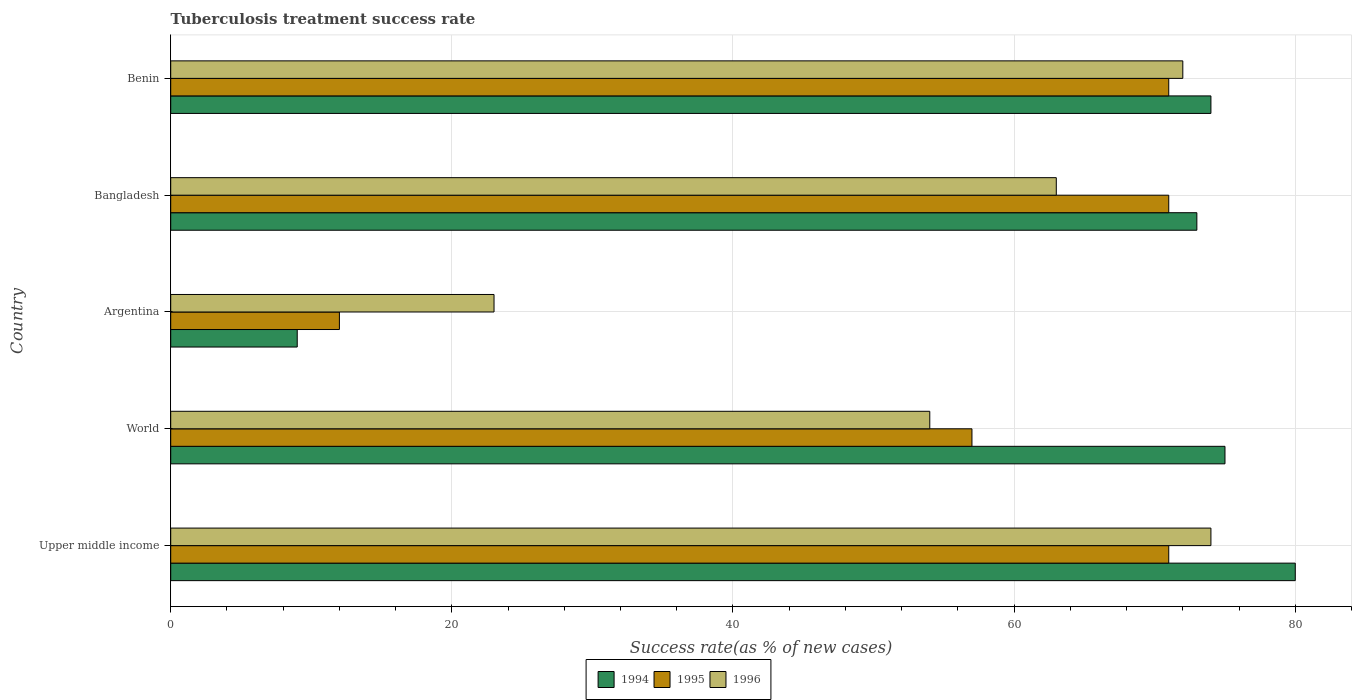How many different coloured bars are there?
Offer a terse response. 3. How many groups of bars are there?
Your answer should be compact. 5. How many bars are there on the 4th tick from the top?
Keep it short and to the point. 3. How many bars are there on the 1st tick from the bottom?
Keep it short and to the point. 3. In how many cases, is the number of bars for a given country not equal to the number of legend labels?
Ensure brevity in your answer.  0. In which country was the tuberculosis treatment success rate in 1995 maximum?
Offer a very short reply. Upper middle income. What is the total tuberculosis treatment success rate in 1994 in the graph?
Give a very brief answer. 311. What is the difference between the tuberculosis treatment success rate in 1995 in Argentina and the tuberculosis treatment success rate in 1996 in Benin?
Offer a terse response. -60. What is the average tuberculosis treatment success rate in 1996 per country?
Provide a succinct answer. 57.2. What is the difference between the tuberculosis treatment success rate in 1995 and tuberculosis treatment success rate in 1996 in Argentina?
Offer a terse response. -11. What is the ratio of the tuberculosis treatment success rate in 1994 in Benin to that in World?
Ensure brevity in your answer.  0.99. Is the difference between the tuberculosis treatment success rate in 1995 in Bangladesh and Benin greater than the difference between the tuberculosis treatment success rate in 1996 in Bangladesh and Benin?
Provide a short and direct response. Yes. What is the difference between the highest and the second highest tuberculosis treatment success rate in 1995?
Your answer should be compact. 0. What is the difference between the highest and the lowest tuberculosis treatment success rate in 1996?
Provide a succinct answer. 51. In how many countries, is the tuberculosis treatment success rate in 1996 greater than the average tuberculosis treatment success rate in 1996 taken over all countries?
Provide a short and direct response. 3. Is the sum of the tuberculosis treatment success rate in 1996 in Argentina and Upper middle income greater than the maximum tuberculosis treatment success rate in 1995 across all countries?
Offer a very short reply. Yes. What does the 2nd bar from the top in Benin represents?
Your answer should be very brief. 1995. What does the 2nd bar from the bottom in World represents?
Your answer should be very brief. 1995. Is it the case that in every country, the sum of the tuberculosis treatment success rate in 1994 and tuberculosis treatment success rate in 1995 is greater than the tuberculosis treatment success rate in 1996?
Ensure brevity in your answer.  No. Are all the bars in the graph horizontal?
Give a very brief answer. Yes. How many countries are there in the graph?
Provide a short and direct response. 5. What is the difference between two consecutive major ticks on the X-axis?
Keep it short and to the point. 20. Does the graph contain any zero values?
Your answer should be compact. No. What is the title of the graph?
Your answer should be very brief. Tuberculosis treatment success rate. What is the label or title of the X-axis?
Provide a succinct answer. Success rate(as % of new cases). What is the Success rate(as % of new cases) of 1995 in Upper middle income?
Ensure brevity in your answer.  71. What is the Success rate(as % of new cases) of 1996 in Upper middle income?
Offer a very short reply. 74. What is the Success rate(as % of new cases) of 1996 in World?
Your answer should be compact. 54. What is the Success rate(as % of new cases) in 1994 in Argentina?
Offer a terse response. 9. What is the Success rate(as % of new cases) in 1996 in Argentina?
Your answer should be very brief. 23. What is the Success rate(as % of new cases) in 1994 in Bangladesh?
Provide a short and direct response. 73. What is the Success rate(as % of new cases) in 1995 in Bangladesh?
Your response must be concise. 71. What is the Success rate(as % of new cases) of 1996 in Bangladesh?
Provide a short and direct response. 63. What is the Success rate(as % of new cases) of 1994 in Benin?
Your response must be concise. 74. What is the Success rate(as % of new cases) in 1996 in Benin?
Offer a very short reply. 72. Across all countries, what is the maximum Success rate(as % of new cases) in 1995?
Provide a succinct answer. 71. Across all countries, what is the maximum Success rate(as % of new cases) in 1996?
Your answer should be very brief. 74. Across all countries, what is the minimum Success rate(as % of new cases) of 1994?
Your response must be concise. 9. Across all countries, what is the minimum Success rate(as % of new cases) in 1995?
Provide a succinct answer. 12. Across all countries, what is the minimum Success rate(as % of new cases) of 1996?
Give a very brief answer. 23. What is the total Success rate(as % of new cases) in 1994 in the graph?
Your answer should be very brief. 311. What is the total Success rate(as % of new cases) of 1995 in the graph?
Your answer should be very brief. 282. What is the total Success rate(as % of new cases) of 1996 in the graph?
Offer a very short reply. 286. What is the difference between the Success rate(as % of new cases) of 1994 in Upper middle income and that in World?
Make the answer very short. 5. What is the difference between the Success rate(as % of new cases) of 1995 in Upper middle income and that in World?
Keep it short and to the point. 14. What is the difference between the Success rate(as % of new cases) of 1995 in Upper middle income and that in Argentina?
Ensure brevity in your answer.  59. What is the difference between the Success rate(as % of new cases) of 1995 in Upper middle income and that in Bangladesh?
Ensure brevity in your answer.  0. What is the difference between the Success rate(as % of new cases) of 1996 in Upper middle income and that in Bangladesh?
Provide a short and direct response. 11. What is the difference between the Success rate(as % of new cases) of 1994 in Upper middle income and that in Benin?
Ensure brevity in your answer.  6. What is the difference between the Success rate(as % of new cases) in 1995 in Upper middle income and that in Benin?
Your answer should be compact. 0. What is the difference between the Success rate(as % of new cases) of 1995 in World and that in Bangladesh?
Ensure brevity in your answer.  -14. What is the difference between the Success rate(as % of new cases) of 1994 in World and that in Benin?
Your answer should be compact. 1. What is the difference between the Success rate(as % of new cases) of 1996 in World and that in Benin?
Ensure brevity in your answer.  -18. What is the difference between the Success rate(as % of new cases) in 1994 in Argentina and that in Bangladesh?
Your response must be concise. -64. What is the difference between the Success rate(as % of new cases) in 1995 in Argentina and that in Bangladesh?
Your response must be concise. -59. What is the difference between the Success rate(as % of new cases) of 1996 in Argentina and that in Bangladesh?
Your answer should be very brief. -40. What is the difference between the Success rate(as % of new cases) in 1994 in Argentina and that in Benin?
Offer a very short reply. -65. What is the difference between the Success rate(as % of new cases) in 1995 in Argentina and that in Benin?
Keep it short and to the point. -59. What is the difference between the Success rate(as % of new cases) in 1996 in Argentina and that in Benin?
Keep it short and to the point. -49. What is the difference between the Success rate(as % of new cases) of 1996 in Bangladesh and that in Benin?
Offer a terse response. -9. What is the difference between the Success rate(as % of new cases) in 1994 in Upper middle income and the Success rate(as % of new cases) in 1995 in World?
Make the answer very short. 23. What is the difference between the Success rate(as % of new cases) of 1994 in Upper middle income and the Success rate(as % of new cases) of 1996 in World?
Your answer should be compact. 26. What is the difference between the Success rate(as % of new cases) of 1994 in Upper middle income and the Success rate(as % of new cases) of 1995 in Argentina?
Give a very brief answer. 68. What is the difference between the Success rate(as % of new cases) of 1995 in Upper middle income and the Success rate(as % of new cases) of 1996 in Argentina?
Ensure brevity in your answer.  48. What is the difference between the Success rate(as % of new cases) of 1994 in Upper middle income and the Success rate(as % of new cases) of 1995 in Bangladesh?
Provide a short and direct response. 9. What is the difference between the Success rate(as % of new cases) of 1994 in Upper middle income and the Success rate(as % of new cases) of 1996 in Bangladesh?
Ensure brevity in your answer.  17. What is the difference between the Success rate(as % of new cases) in 1994 in Upper middle income and the Success rate(as % of new cases) in 1995 in Benin?
Make the answer very short. 9. What is the difference between the Success rate(as % of new cases) of 1995 in Upper middle income and the Success rate(as % of new cases) of 1996 in Benin?
Give a very brief answer. -1. What is the difference between the Success rate(as % of new cases) in 1994 in World and the Success rate(as % of new cases) in 1995 in Argentina?
Provide a succinct answer. 63. What is the difference between the Success rate(as % of new cases) of 1994 in World and the Success rate(as % of new cases) of 1996 in Argentina?
Keep it short and to the point. 52. What is the difference between the Success rate(as % of new cases) in 1995 in World and the Success rate(as % of new cases) in 1996 in Argentina?
Offer a very short reply. 34. What is the difference between the Success rate(as % of new cases) in 1994 in World and the Success rate(as % of new cases) in 1995 in Bangladesh?
Provide a short and direct response. 4. What is the difference between the Success rate(as % of new cases) in 1994 in World and the Success rate(as % of new cases) in 1996 in Bangladesh?
Your answer should be very brief. 12. What is the difference between the Success rate(as % of new cases) in 1995 in World and the Success rate(as % of new cases) in 1996 in Bangladesh?
Give a very brief answer. -6. What is the difference between the Success rate(as % of new cases) of 1994 in World and the Success rate(as % of new cases) of 1995 in Benin?
Ensure brevity in your answer.  4. What is the difference between the Success rate(as % of new cases) of 1994 in Argentina and the Success rate(as % of new cases) of 1995 in Bangladesh?
Offer a very short reply. -62. What is the difference between the Success rate(as % of new cases) of 1994 in Argentina and the Success rate(as % of new cases) of 1996 in Bangladesh?
Give a very brief answer. -54. What is the difference between the Success rate(as % of new cases) of 1995 in Argentina and the Success rate(as % of new cases) of 1996 in Bangladesh?
Make the answer very short. -51. What is the difference between the Success rate(as % of new cases) in 1994 in Argentina and the Success rate(as % of new cases) in 1995 in Benin?
Give a very brief answer. -62. What is the difference between the Success rate(as % of new cases) of 1994 in Argentina and the Success rate(as % of new cases) of 1996 in Benin?
Your answer should be compact. -63. What is the difference between the Success rate(as % of new cases) in 1995 in Argentina and the Success rate(as % of new cases) in 1996 in Benin?
Offer a very short reply. -60. What is the difference between the Success rate(as % of new cases) of 1994 in Bangladesh and the Success rate(as % of new cases) of 1996 in Benin?
Offer a terse response. 1. What is the average Success rate(as % of new cases) in 1994 per country?
Provide a short and direct response. 62.2. What is the average Success rate(as % of new cases) in 1995 per country?
Your answer should be compact. 56.4. What is the average Success rate(as % of new cases) in 1996 per country?
Provide a short and direct response. 57.2. What is the difference between the Success rate(as % of new cases) of 1994 and Success rate(as % of new cases) of 1995 in Upper middle income?
Your response must be concise. 9. What is the difference between the Success rate(as % of new cases) in 1994 and Success rate(as % of new cases) in 1995 in World?
Your answer should be very brief. 18. What is the difference between the Success rate(as % of new cases) in 1995 and Success rate(as % of new cases) in 1996 in World?
Your answer should be very brief. 3. What is the difference between the Success rate(as % of new cases) in 1994 and Success rate(as % of new cases) in 1995 in Argentina?
Offer a terse response. -3. What is the difference between the Success rate(as % of new cases) of 1995 and Success rate(as % of new cases) of 1996 in Argentina?
Your answer should be compact. -11. What is the difference between the Success rate(as % of new cases) in 1994 and Success rate(as % of new cases) in 1996 in Bangladesh?
Offer a terse response. 10. What is the difference between the Success rate(as % of new cases) in 1995 and Success rate(as % of new cases) in 1996 in Benin?
Offer a terse response. -1. What is the ratio of the Success rate(as % of new cases) in 1994 in Upper middle income to that in World?
Your answer should be very brief. 1.07. What is the ratio of the Success rate(as % of new cases) in 1995 in Upper middle income to that in World?
Make the answer very short. 1.25. What is the ratio of the Success rate(as % of new cases) in 1996 in Upper middle income to that in World?
Keep it short and to the point. 1.37. What is the ratio of the Success rate(as % of new cases) of 1994 in Upper middle income to that in Argentina?
Offer a very short reply. 8.89. What is the ratio of the Success rate(as % of new cases) in 1995 in Upper middle income to that in Argentina?
Your response must be concise. 5.92. What is the ratio of the Success rate(as % of new cases) in 1996 in Upper middle income to that in Argentina?
Make the answer very short. 3.22. What is the ratio of the Success rate(as % of new cases) of 1994 in Upper middle income to that in Bangladesh?
Your answer should be compact. 1.1. What is the ratio of the Success rate(as % of new cases) in 1995 in Upper middle income to that in Bangladesh?
Provide a short and direct response. 1. What is the ratio of the Success rate(as % of new cases) of 1996 in Upper middle income to that in Bangladesh?
Keep it short and to the point. 1.17. What is the ratio of the Success rate(as % of new cases) of 1994 in Upper middle income to that in Benin?
Keep it short and to the point. 1.08. What is the ratio of the Success rate(as % of new cases) in 1995 in Upper middle income to that in Benin?
Provide a short and direct response. 1. What is the ratio of the Success rate(as % of new cases) in 1996 in Upper middle income to that in Benin?
Ensure brevity in your answer.  1.03. What is the ratio of the Success rate(as % of new cases) of 1994 in World to that in Argentina?
Your response must be concise. 8.33. What is the ratio of the Success rate(as % of new cases) of 1995 in World to that in Argentina?
Your answer should be compact. 4.75. What is the ratio of the Success rate(as % of new cases) in 1996 in World to that in Argentina?
Your response must be concise. 2.35. What is the ratio of the Success rate(as % of new cases) in 1994 in World to that in Bangladesh?
Provide a short and direct response. 1.03. What is the ratio of the Success rate(as % of new cases) of 1995 in World to that in Bangladesh?
Your response must be concise. 0.8. What is the ratio of the Success rate(as % of new cases) of 1994 in World to that in Benin?
Ensure brevity in your answer.  1.01. What is the ratio of the Success rate(as % of new cases) in 1995 in World to that in Benin?
Offer a very short reply. 0.8. What is the ratio of the Success rate(as % of new cases) in 1994 in Argentina to that in Bangladesh?
Make the answer very short. 0.12. What is the ratio of the Success rate(as % of new cases) of 1995 in Argentina to that in Bangladesh?
Make the answer very short. 0.17. What is the ratio of the Success rate(as % of new cases) in 1996 in Argentina to that in Bangladesh?
Offer a very short reply. 0.37. What is the ratio of the Success rate(as % of new cases) in 1994 in Argentina to that in Benin?
Provide a short and direct response. 0.12. What is the ratio of the Success rate(as % of new cases) of 1995 in Argentina to that in Benin?
Give a very brief answer. 0.17. What is the ratio of the Success rate(as % of new cases) in 1996 in Argentina to that in Benin?
Keep it short and to the point. 0.32. What is the ratio of the Success rate(as % of new cases) in 1994 in Bangladesh to that in Benin?
Your answer should be compact. 0.99. What is the ratio of the Success rate(as % of new cases) in 1995 in Bangladesh to that in Benin?
Provide a short and direct response. 1. What is the difference between the highest and the second highest Success rate(as % of new cases) in 1994?
Your answer should be very brief. 5. What is the difference between the highest and the second highest Success rate(as % of new cases) in 1996?
Keep it short and to the point. 2. What is the difference between the highest and the lowest Success rate(as % of new cases) of 1994?
Your response must be concise. 71. What is the difference between the highest and the lowest Success rate(as % of new cases) of 1995?
Keep it short and to the point. 59. What is the difference between the highest and the lowest Success rate(as % of new cases) of 1996?
Provide a succinct answer. 51. 